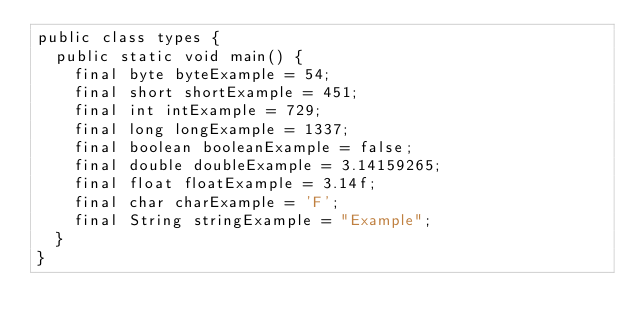Convert code to text. <code><loc_0><loc_0><loc_500><loc_500><_Java_>public class types {
  public static void main() {
    final byte byteExample = 54;
    final short shortExample = 451;
    final int intExample = 729;
    final long longExample = 1337;
    final boolean booleanExample = false;
    final double doubleExample = 3.14159265;
    final float floatExample = 3.14f;
    final char charExample = 'F';
    final String stringExample = "Example";
  }
}
</code> 